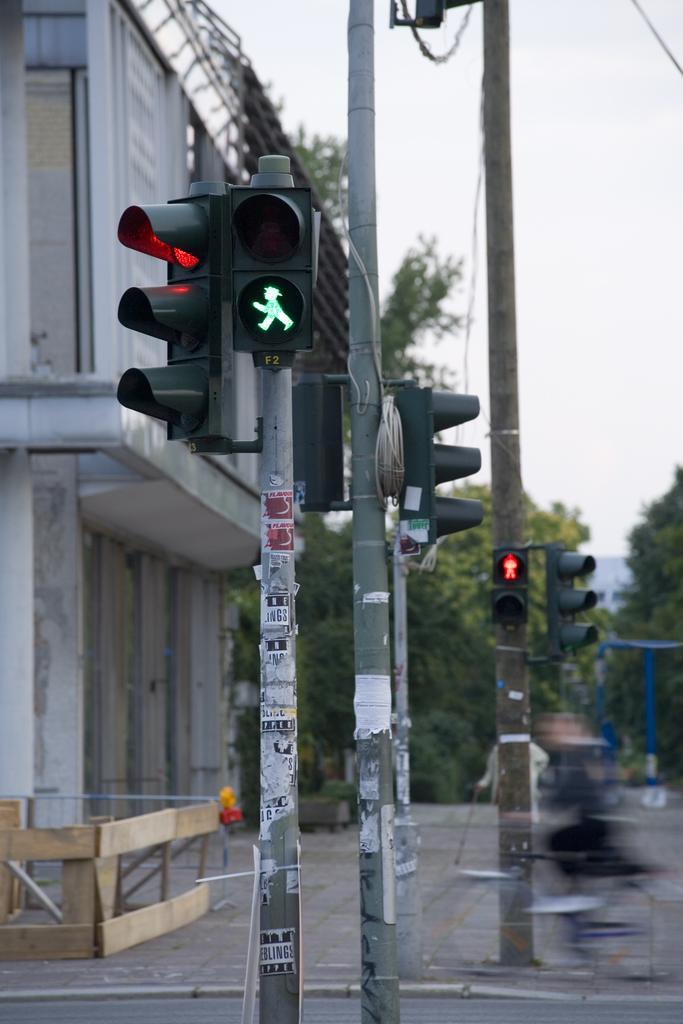Can you describe this image briefly? In this image in the center there are poles. On the left side there is a building and there are trees and the sky is cloudy. 